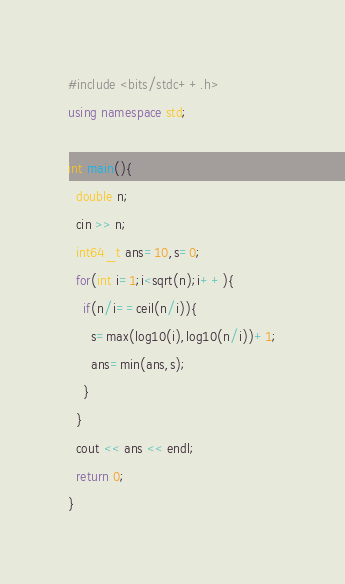<code> <loc_0><loc_0><loc_500><loc_500><_C++_>#include <bits/stdc++.h>
using namespace std;

int main(){
  double n;
  cin >> n;
  int64_t ans=10,s=0;
  for(int i=1;i<sqrt(n);i++){
    if(n/i==ceil(n/i)){
      s=max(log10(i),log10(n/i))+1;
      ans=min(ans,s);
    }
  }
  cout << ans << endl;
  return 0;
}</code> 